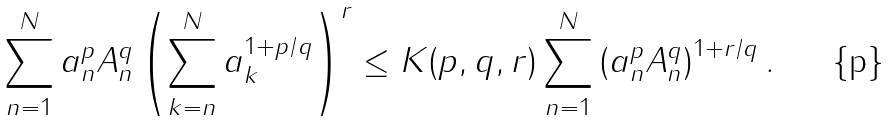<formula> <loc_0><loc_0><loc_500><loc_500>\sum ^ { N } _ { n = 1 } a ^ { p } _ { n } A ^ { q } _ { n } \left ( \sum ^ { N } _ { k = n } a _ { k } ^ { 1 + p / q } \right ) ^ { r } \leq K ( p , q , r ) \sum ^ { N } _ { n = 1 } \left ( a ^ { p } _ { n } A ^ { q } _ { n } \right ) ^ { 1 + r / q } .</formula> 